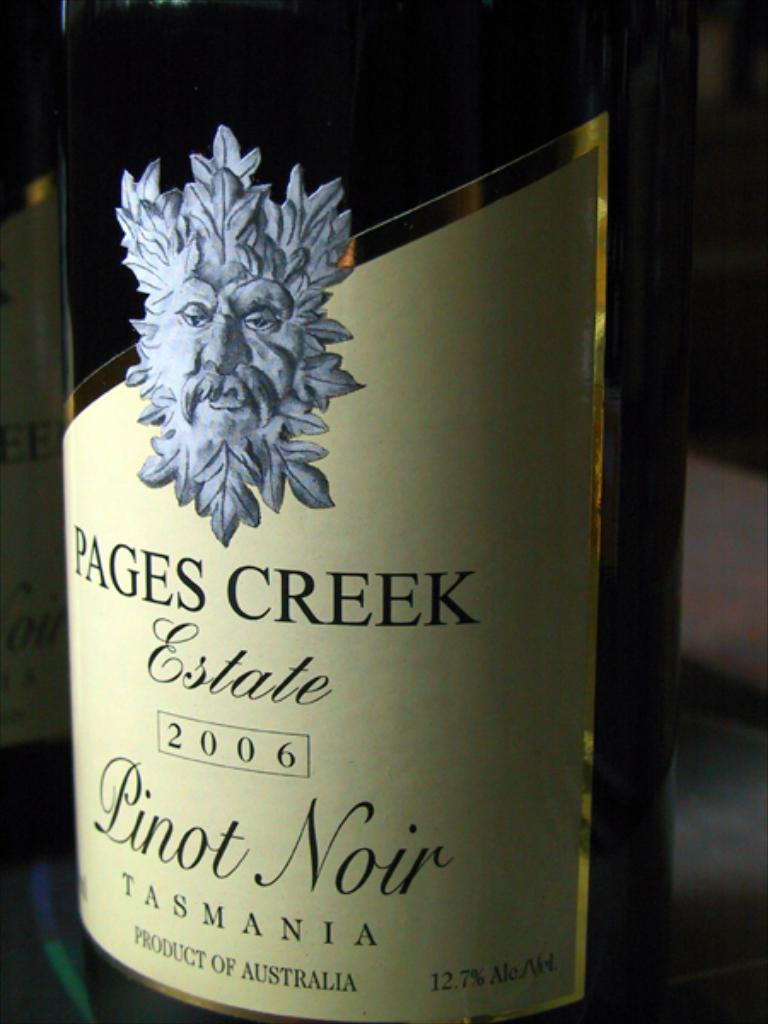Provide a one-sentence caption for the provided image. The bottle of Pinot Noir is a product of Australia. 